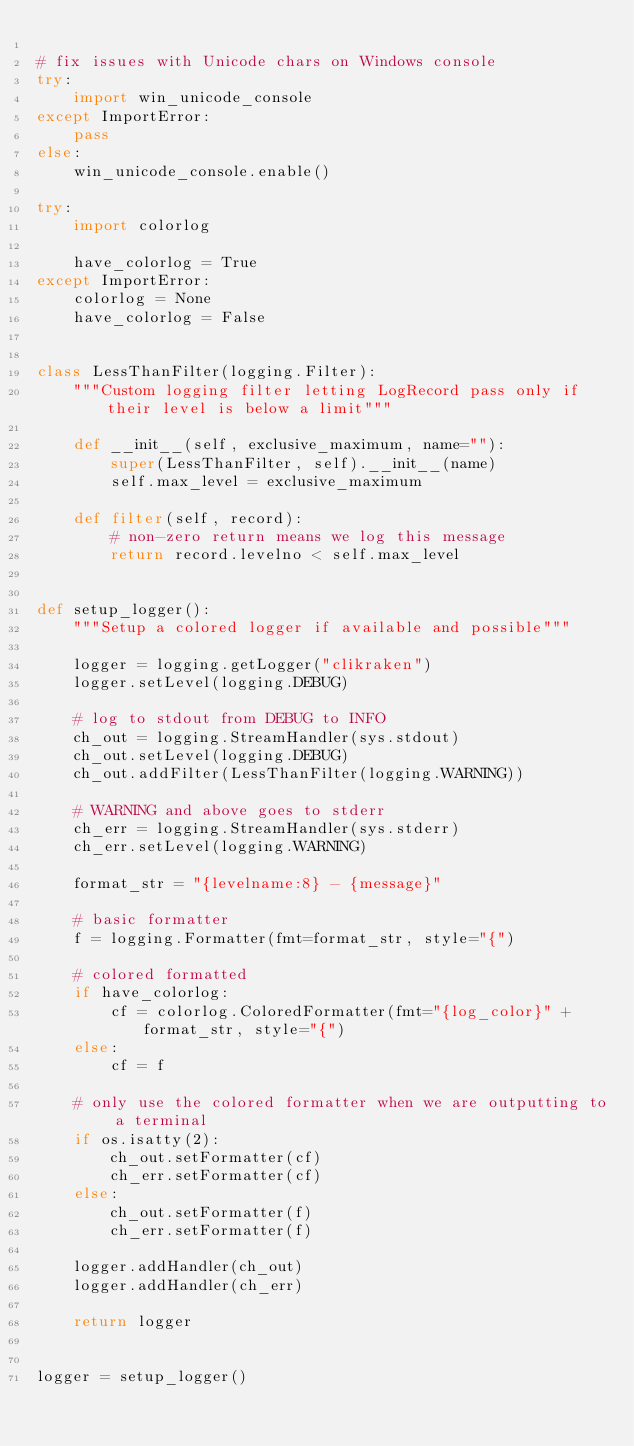Convert code to text. <code><loc_0><loc_0><loc_500><loc_500><_Python_>
# fix issues with Unicode chars on Windows console
try:
    import win_unicode_console
except ImportError:
    pass
else:
    win_unicode_console.enable()

try:
    import colorlog

    have_colorlog = True
except ImportError:
    colorlog = None
    have_colorlog = False


class LessThanFilter(logging.Filter):
    """Custom logging filter letting LogRecord pass only if their level is below a limit"""

    def __init__(self, exclusive_maximum, name=""):
        super(LessThanFilter, self).__init__(name)
        self.max_level = exclusive_maximum

    def filter(self, record):
        # non-zero return means we log this message
        return record.levelno < self.max_level


def setup_logger():
    """Setup a colored logger if available and possible"""

    logger = logging.getLogger("clikraken")
    logger.setLevel(logging.DEBUG)

    # log to stdout from DEBUG to INFO
    ch_out = logging.StreamHandler(sys.stdout)
    ch_out.setLevel(logging.DEBUG)
    ch_out.addFilter(LessThanFilter(logging.WARNING))

    # WARNING and above goes to stderr
    ch_err = logging.StreamHandler(sys.stderr)
    ch_err.setLevel(logging.WARNING)

    format_str = "{levelname:8} - {message}"

    # basic formatter
    f = logging.Formatter(fmt=format_str, style="{")

    # colored formatted
    if have_colorlog:
        cf = colorlog.ColoredFormatter(fmt="{log_color}" + format_str, style="{")
    else:
        cf = f

    # only use the colored formatter when we are outputting to a terminal
    if os.isatty(2):
        ch_out.setFormatter(cf)
        ch_err.setFormatter(cf)
    else:
        ch_out.setFormatter(f)
        ch_err.setFormatter(f)

    logger.addHandler(ch_out)
    logger.addHandler(ch_err)

    return logger


logger = setup_logger()
</code> 